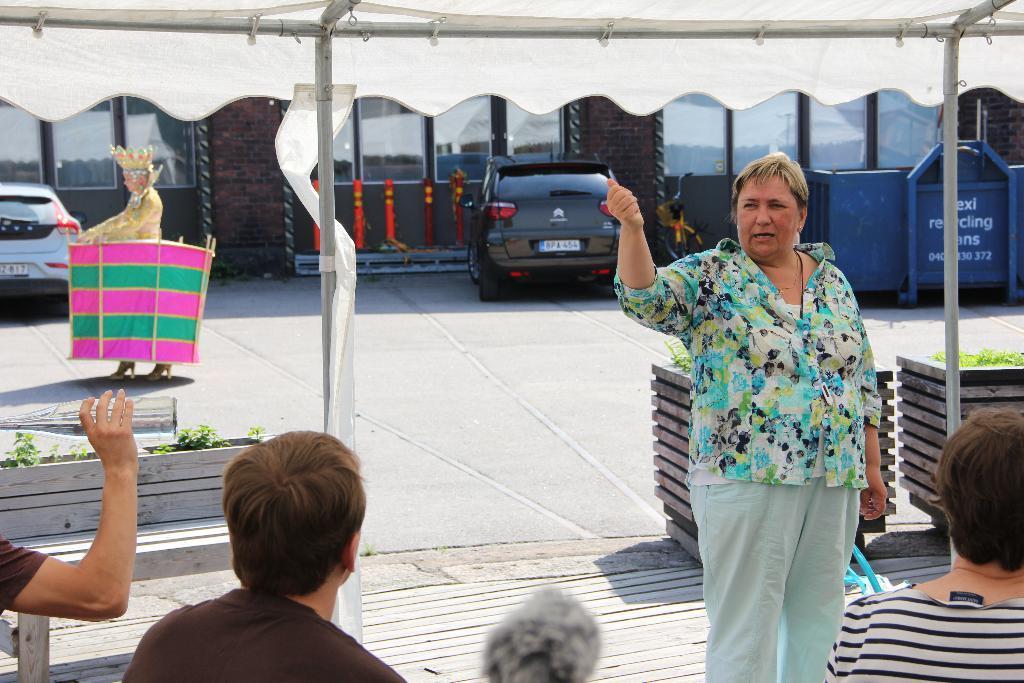Can you describe this image briefly? In this image I can see people, tent, poles, plants, road, vehicles, windows, walls and objects. Among them one person is holding a bottle. 